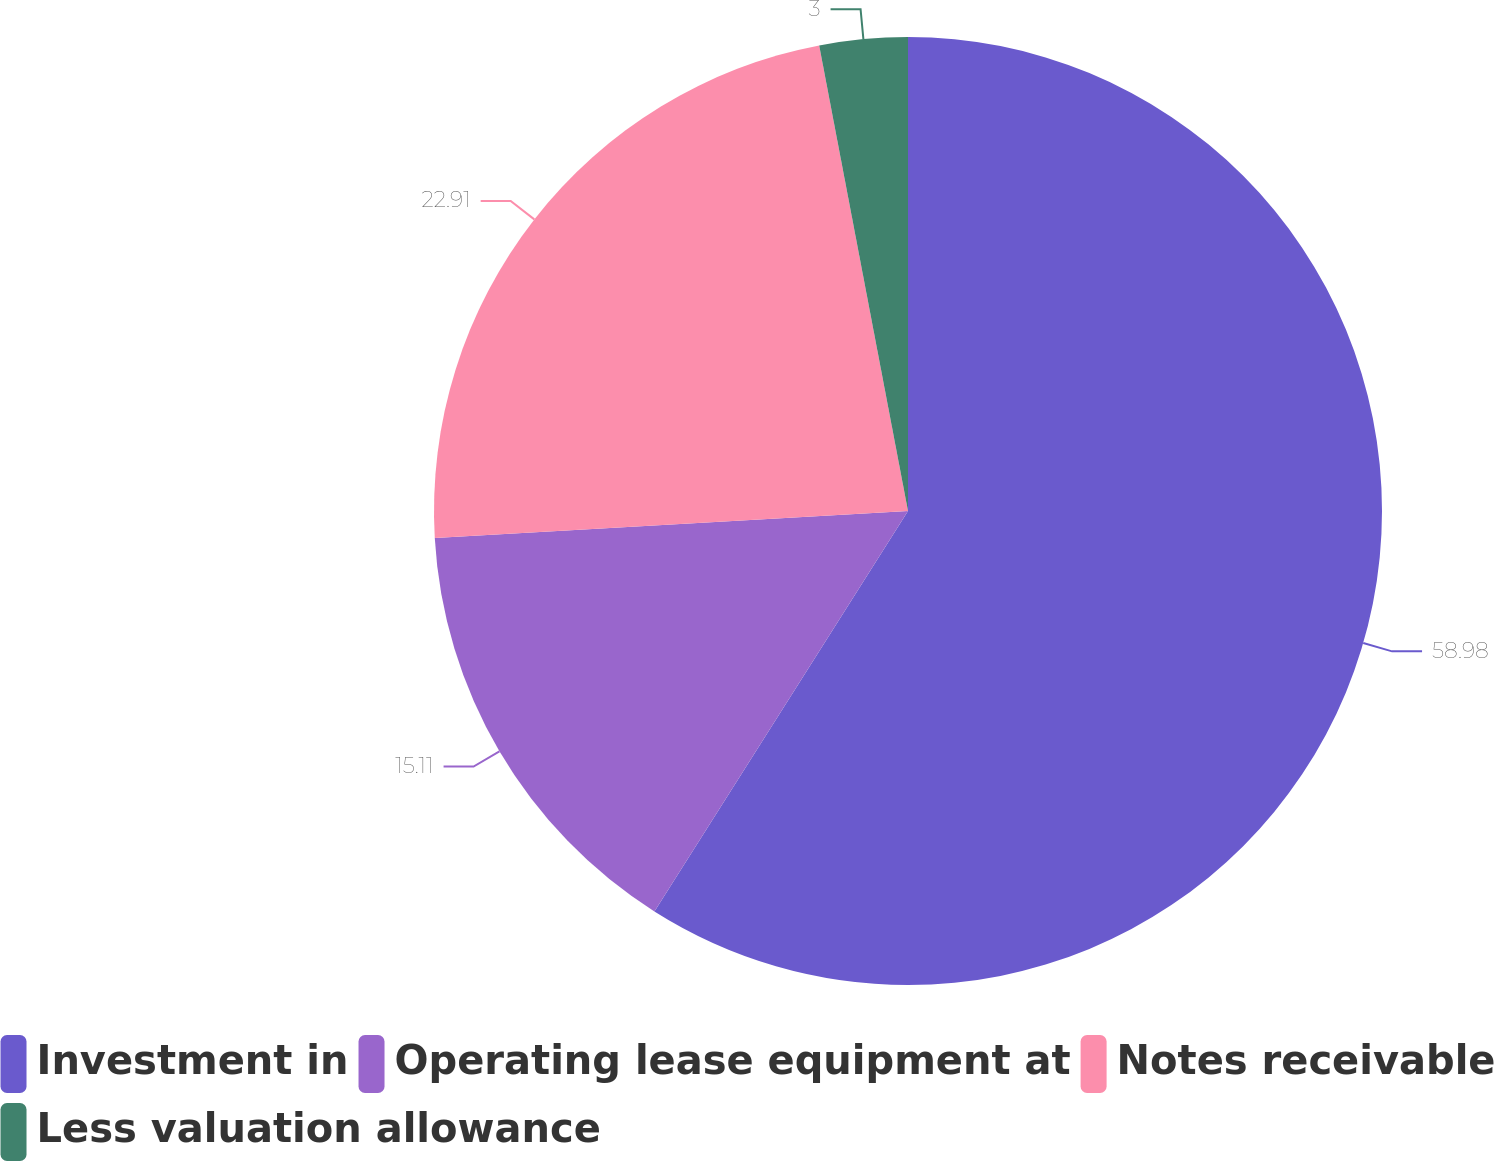<chart> <loc_0><loc_0><loc_500><loc_500><pie_chart><fcel>Investment in<fcel>Operating lease equipment at<fcel>Notes receivable<fcel>Less valuation allowance<nl><fcel>58.99%<fcel>15.11%<fcel>22.91%<fcel>3.0%<nl></chart> 